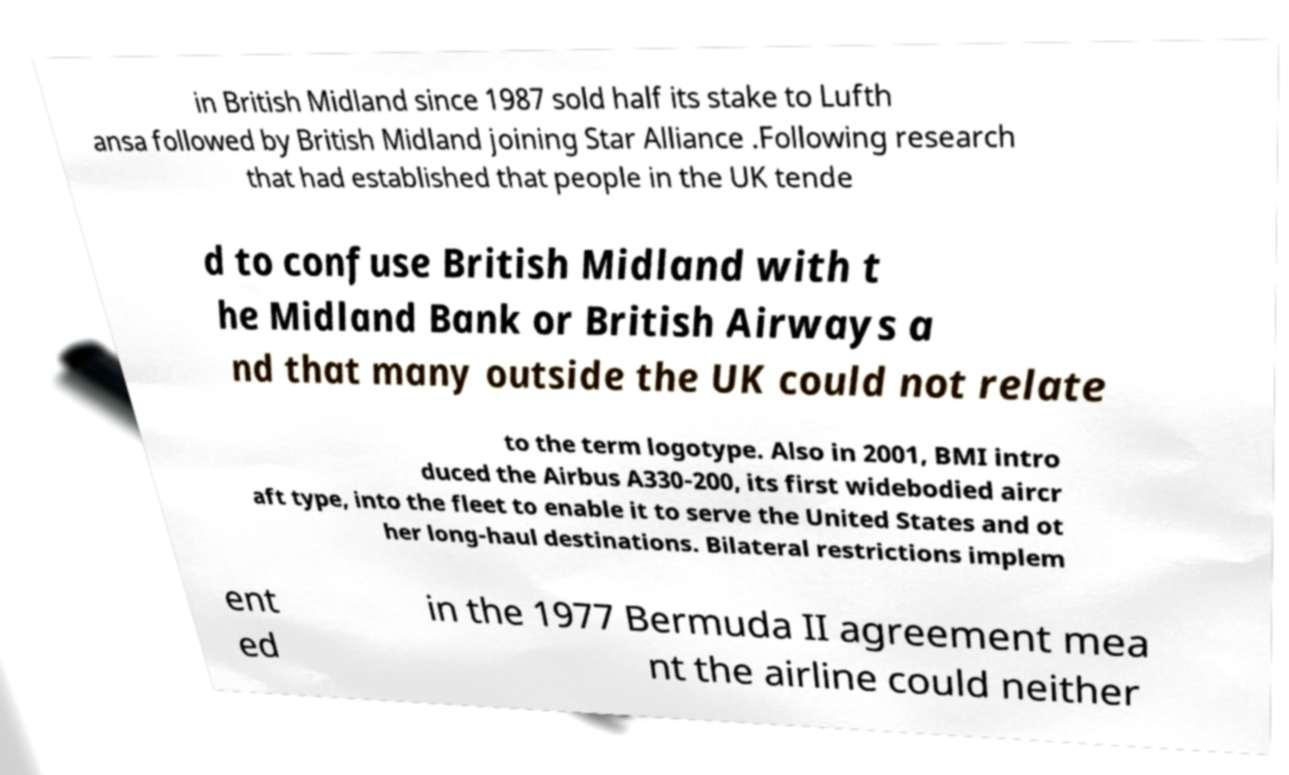Can you read and provide the text displayed in the image?This photo seems to have some interesting text. Can you extract and type it out for me? in British Midland since 1987 sold half its stake to Lufth ansa followed by British Midland joining Star Alliance .Following research that had established that people in the UK tende d to confuse British Midland with t he Midland Bank or British Airways a nd that many outside the UK could not relate to the term logotype. Also in 2001, BMI intro duced the Airbus A330-200, its first widebodied aircr aft type, into the fleet to enable it to serve the United States and ot her long-haul destinations. Bilateral restrictions implem ent ed in the 1977 Bermuda II agreement mea nt the airline could neither 